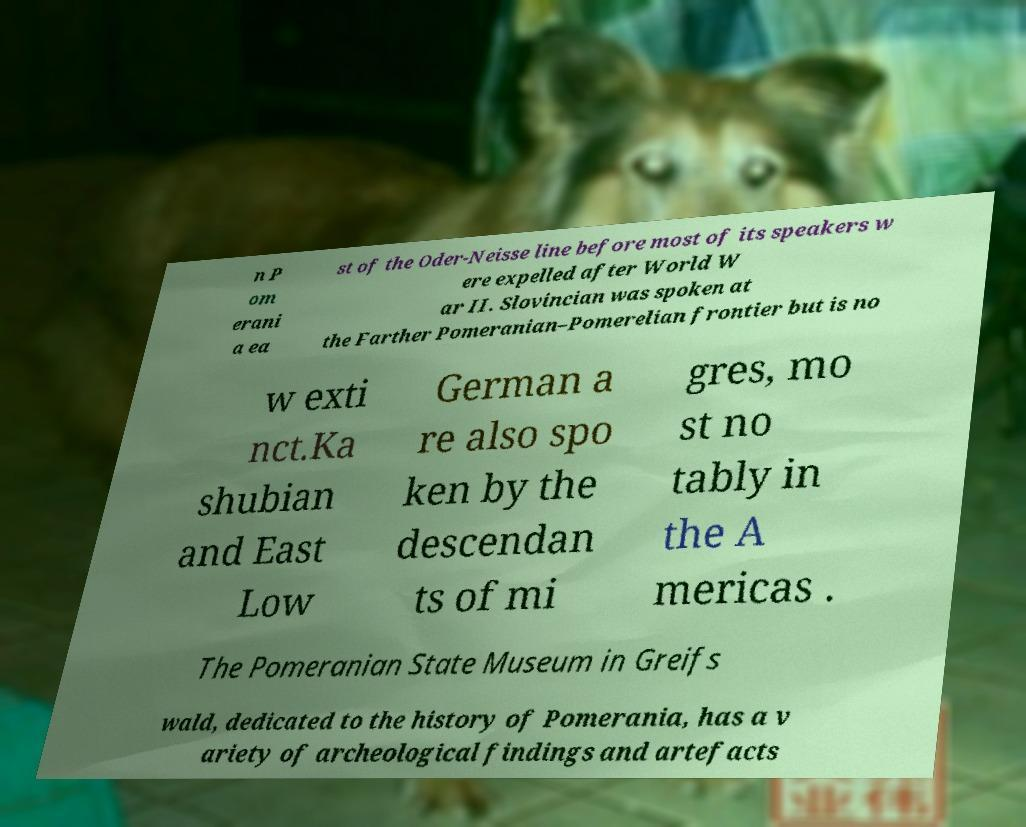Please identify and transcribe the text found in this image. n P om erani a ea st of the Oder-Neisse line before most of its speakers w ere expelled after World W ar II. Slovincian was spoken at the Farther Pomeranian–Pomerelian frontier but is no w exti nct.Ka shubian and East Low German a re also spo ken by the descendan ts of mi gres, mo st no tably in the A mericas . The Pomeranian State Museum in Greifs wald, dedicated to the history of Pomerania, has a v ariety of archeological findings and artefacts 